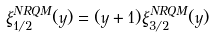<formula> <loc_0><loc_0><loc_500><loc_500>\xi _ { 1 / 2 } ^ { N R Q M } ( y ) = ( y + 1 ) \xi _ { 3 / 2 } ^ { N R Q M } ( y )</formula> 